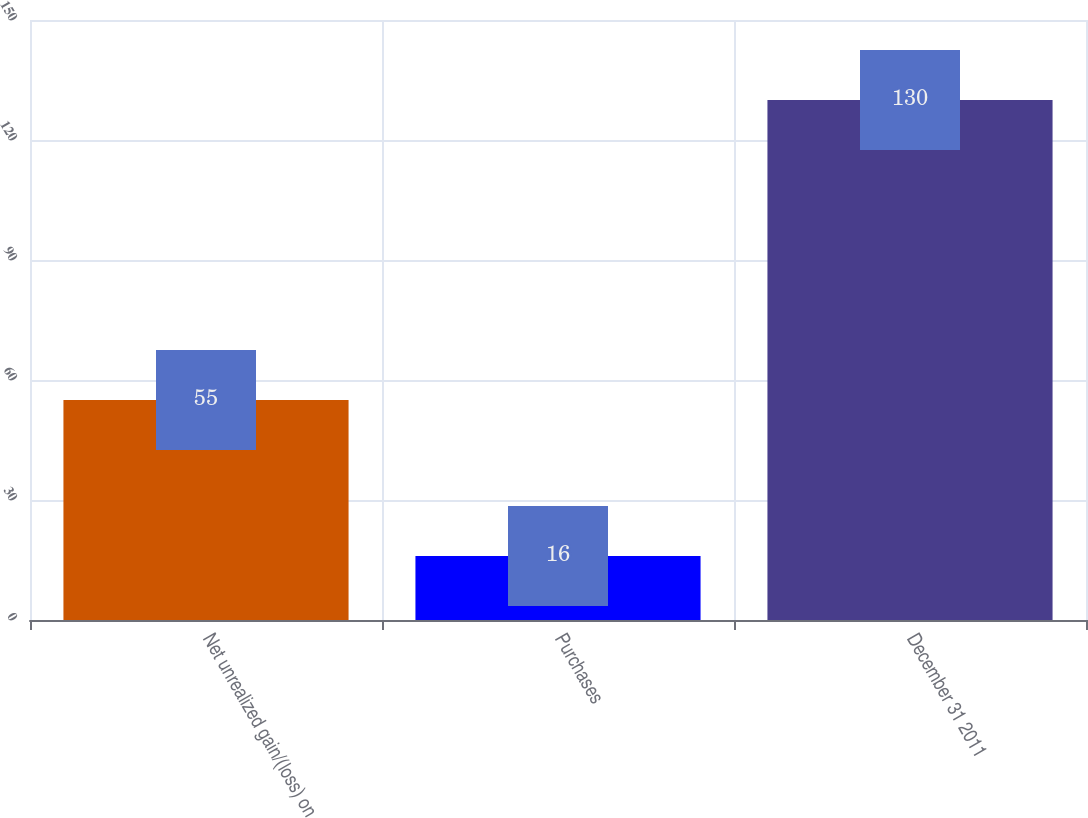Convert chart to OTSL. <chart><loc_0><loc_0><loc_500><loc_500><bar_chart><fcel>Net unrealized gain/(loss) on<fcel>Purchases<fcel>December 31 2011<nl><fcel>55<fcel>16<fcel>130<nl></chart> 